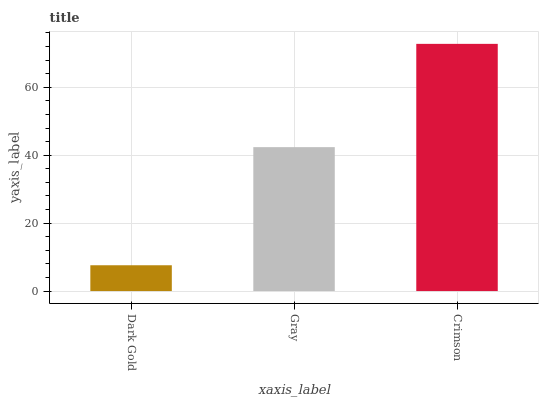Is Gray the minimum?
Answer yes or no. No. Is Gray the maximum?
Answer yes or no. No. Is Gray greater than Dark Gold?
Answer yes or no. Yes. Is Dark Gold less than Gray?
Answer yes or no. Yes. Is Dark Gold greater than Gray?
Answer yes or no. No. Is Gray less than Dark Gold?
Answer yes or no. No. Is Gray the high median?
Answer yes or no. Yes. Is Gray the low median?
Answer yes or no. Yes. Is Dark Gold the high median?
Answer yes or no. No. Is Crimson the low median?
Answer yes or no. No. 